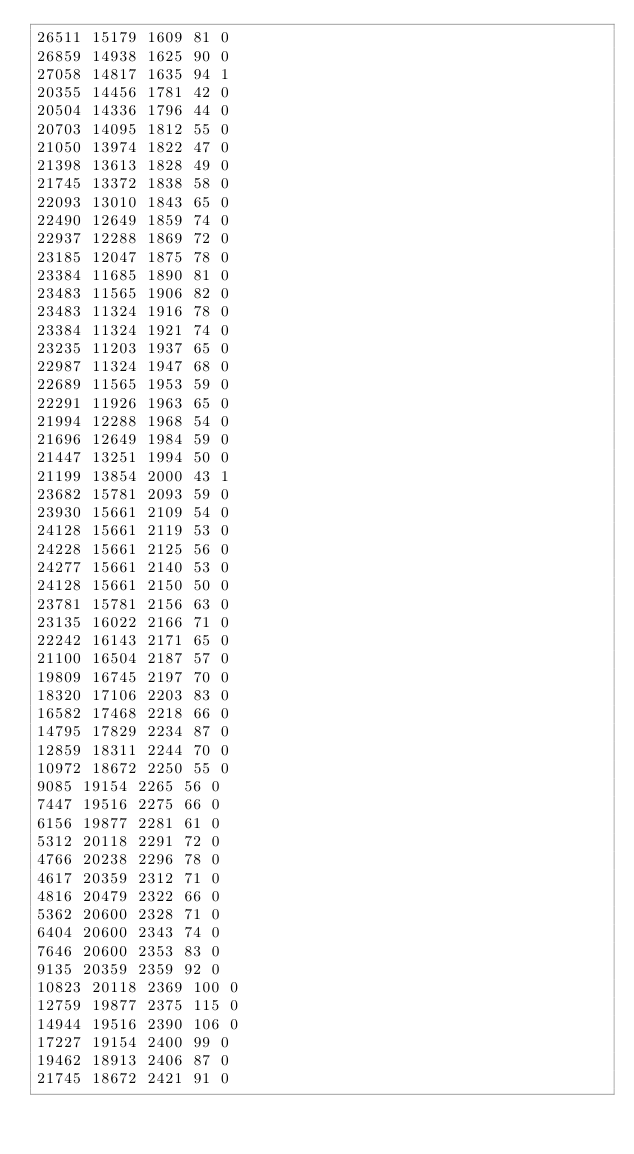<code> <loc_0><loc_0><loc_500><loc_500><_SML_>26511 15179 1609 81 0
26859 14938 1625 90 0
27058 14817 1635 94 1
20355 14456 1781 42 0
20504 14336 1796 44 0
20703 14095 1812 55 0
21050 13974 1822 47 0
21398 13613 1828 49 0
21745 13372 1838 58 0
22093 13010 1843 65 0
22490 12649 1859 74 0
22937 12288 1869 72 0
23185 12047 1875 78 0
23384 11685 1890 81 0
23483 11565 1906 82 0
23483 11324 1916 78 0
23384 11324 1921 74 0
23235 11203 1937 65 0
22987 11324 1947 68 0
22689 11565 1953 59 0
22291 11926 1963 65 0
21994 12288 1968 54 0
21696 12649 1984 59 0
21447 13251 1994 50 0
21199 13854 2000 43 1
23682 15781 2093 59 0
23930 15661 2109 54 0
24128 15661 2119 53 0
24228 15661 2125 56 0
24277 15661 2140 53 0
24128 15661 2150 50 0
23781 15781 2156 63 0
23135 16022 2166 71 0
22242 16143 2171 65 0
21100 16504 2187 57 0
19809 16745 2197 70 0
18320 17106 2203 83 0
16582 17468 2218 66 0
14795 17829 2234 87 0
12859 18311 2244 70 0
10972 18672 2250 55 0
9085 19154 2265 56 0
7447 19516 2275 66 0
6156 19877 2281 61 0
5312 20118 2291 72 0
4766 20238 2296 78 0
4617 20359 2312 71 0
4816 20479 2322 66 0
5362 20600 2328 71 0
6404 20600 2343 74 0
7646 20600 2353 83 0
9135 20359 2359 92 0
10823 20118 2369 100 0
12759 19877 2375 115 0
14944 19516 2390 106 0
17227 19154 2400 99 0
19462 18913 2406 87 0
21745 18672 2421 91 0</code> 